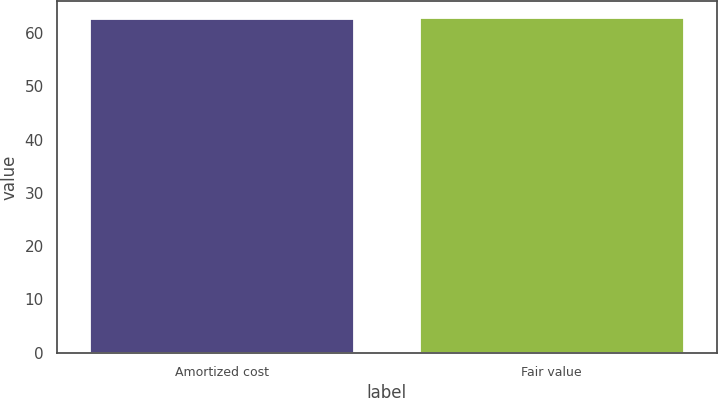<chart> <loc_0><loc_0><loc_500><loc_500><bar_chart><fcel>Amortized cost<fcel>Fair value<nl><fcel>62.7<fcel>62.8<nl></chart> 